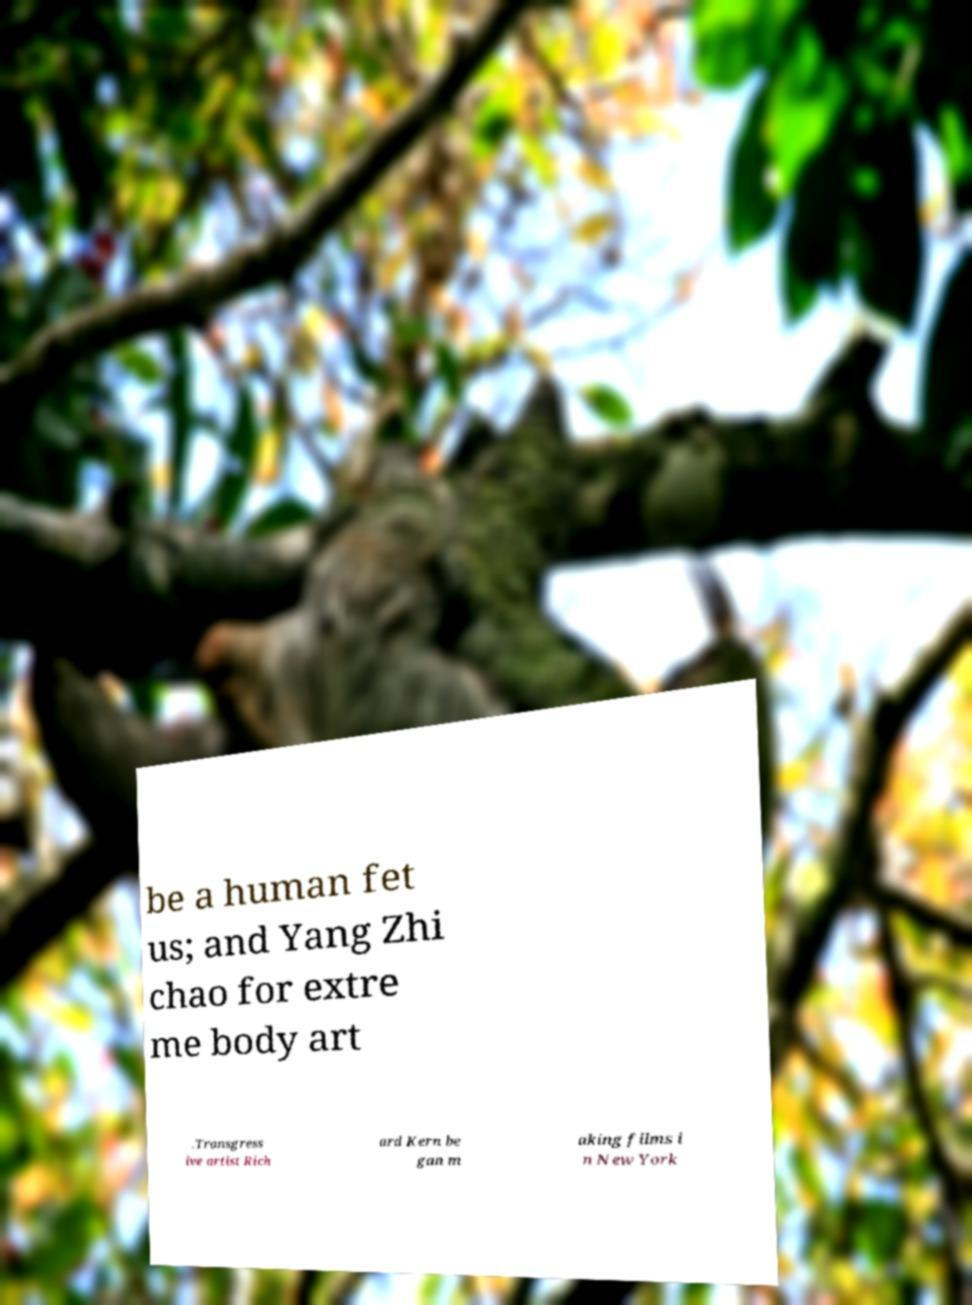What messages or text are displayed in this image? I need them in a readable, typed format. be a human fet us; and Yang Zhi chao for extre me body art .Transgress ive artist Rich ard Kern be gan m aking films i n New York 